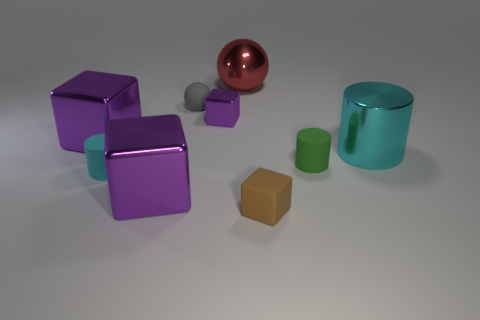How many rubber cylinders are there? Based on the image, there appears to be only one cylinder made of rubber, which is the green one. 